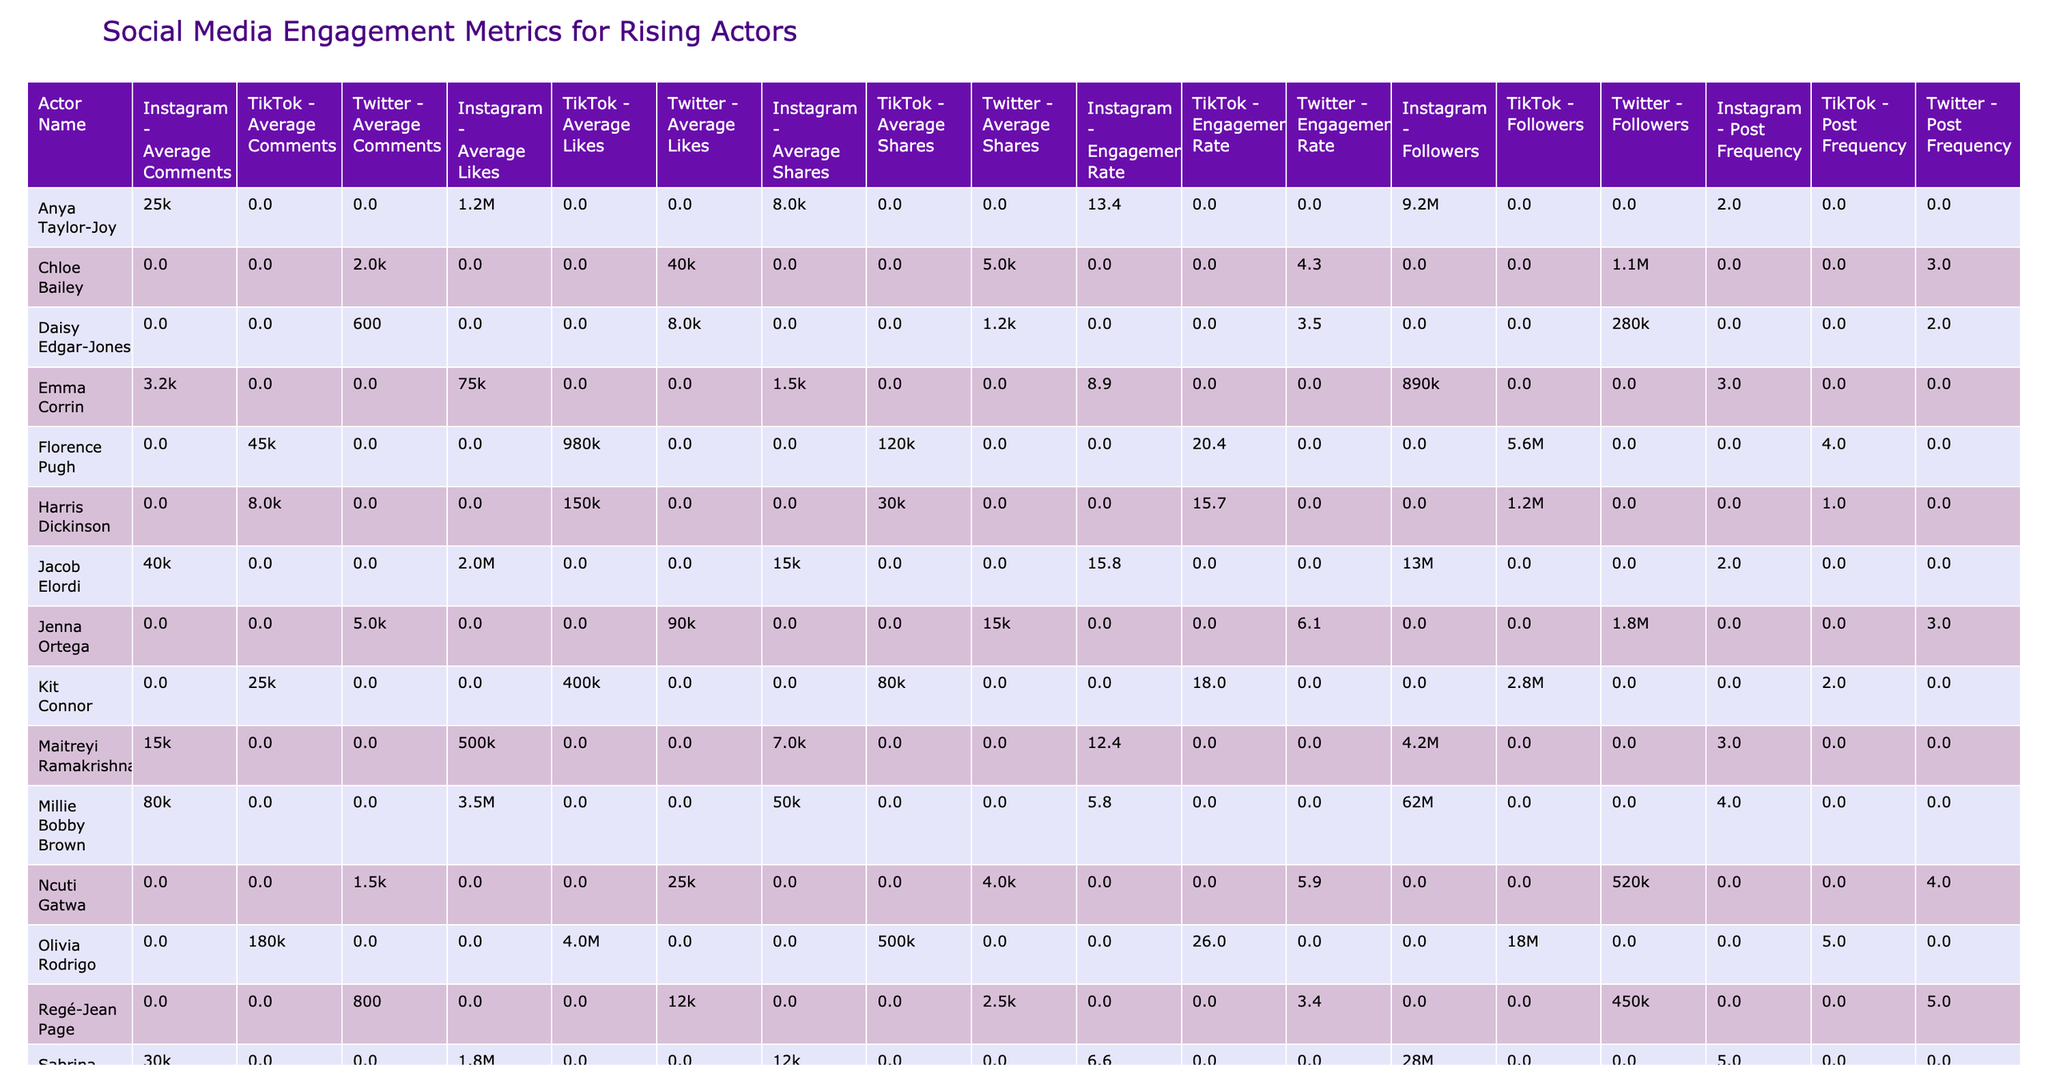What is the engagement rate of Emma Corrin on Instagram? By locating Emma Corrin's row in the Instagram column, I can see that her engagement rate is listed directly beside her name. Therefore, the engagement rate for her on Instagram is 8.9.
Answer: 8.9 Which actor has the most followers on TikTok? I compare the "Followers" values for all actors listed under the TikTok platform. Florence Pugh has 5,600,000 followers, Olivia Rodrigo has 18,000,000, and Zendaya has 28,000,000. The highest number is 28,000,000 followers for Zendaya.
Answer: Zendaya What is the average engagement rate for actors on Twitter? For this, I look at the engagement rates of all actors on Twitter, which are 3.4 (Regé-Jean Page), 10.8 (Timothée Chalamet), 6.1 (Jenna Ortega), 3.5 (Daisy Edgar-Jones), and 5.9 (Ncuti Gatwa). Adding these rates gives a total of 29.7 and dividing by 5 actors results in an average of 5.94.
Answer: 5.94 Is the average number of likes per post for Millie Bobby Brown greater than 3 million? The average likes for Millie Bobby Brown is 3,500,000. This is more than 3 million, thus affirming the statement to be true.
Answer: Yes Which actor has a higher average number of shares on Instagram: Jacob Elordi or Sydney Sweeney? For this question, I need to check the average shares for both actors on Instagram. Jacob Elordi has 15,000 shares, while Sydney Sweeney has 20,000 shares. Since 20,000 is greater than 15,000, Sydney Sweeney has the higher average shares.
Answer: Sydney Sweeney What is the total number of followers for the two actors with the lowest followers on Twitter? I will first identify the follower counts for actors on Twitter, which are 280,000 (Daisy Edgar-Jones) and 450,000 (Regé-Jean Page). Adding these yields a total of 730,000 followers.
Answer: 730,000 Which platform has the highest average engagement rate across all actors? I will calculate the average engagement rate for each platform by summing the rates for actors under each platform and dividing by the number of actors. For Instagram, the average is calculated from several entries (adding and dividing), TikTok values yield a higher average of 21.9, and for Twitter, the calculated average is notably lower. TikTok returns the highest average engagement rate overall.
Answer: TikTok How many posts on average does Tom Holland make? Looking at the "Post Frequency" value listed under Tom Holland in the table, it shows that he posts once a day on average.
Answer: 1 